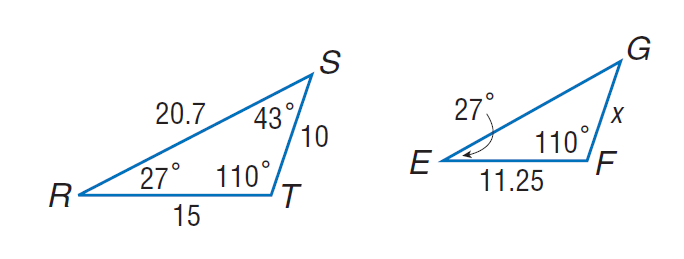Answer the mathemtical geometry problem and directly provide the correct option letter.
Question: Each pair of polygons is similar. Find E G.
Choices: A: 5.675 B: 11.25 C: 15.525 D: 66 C 